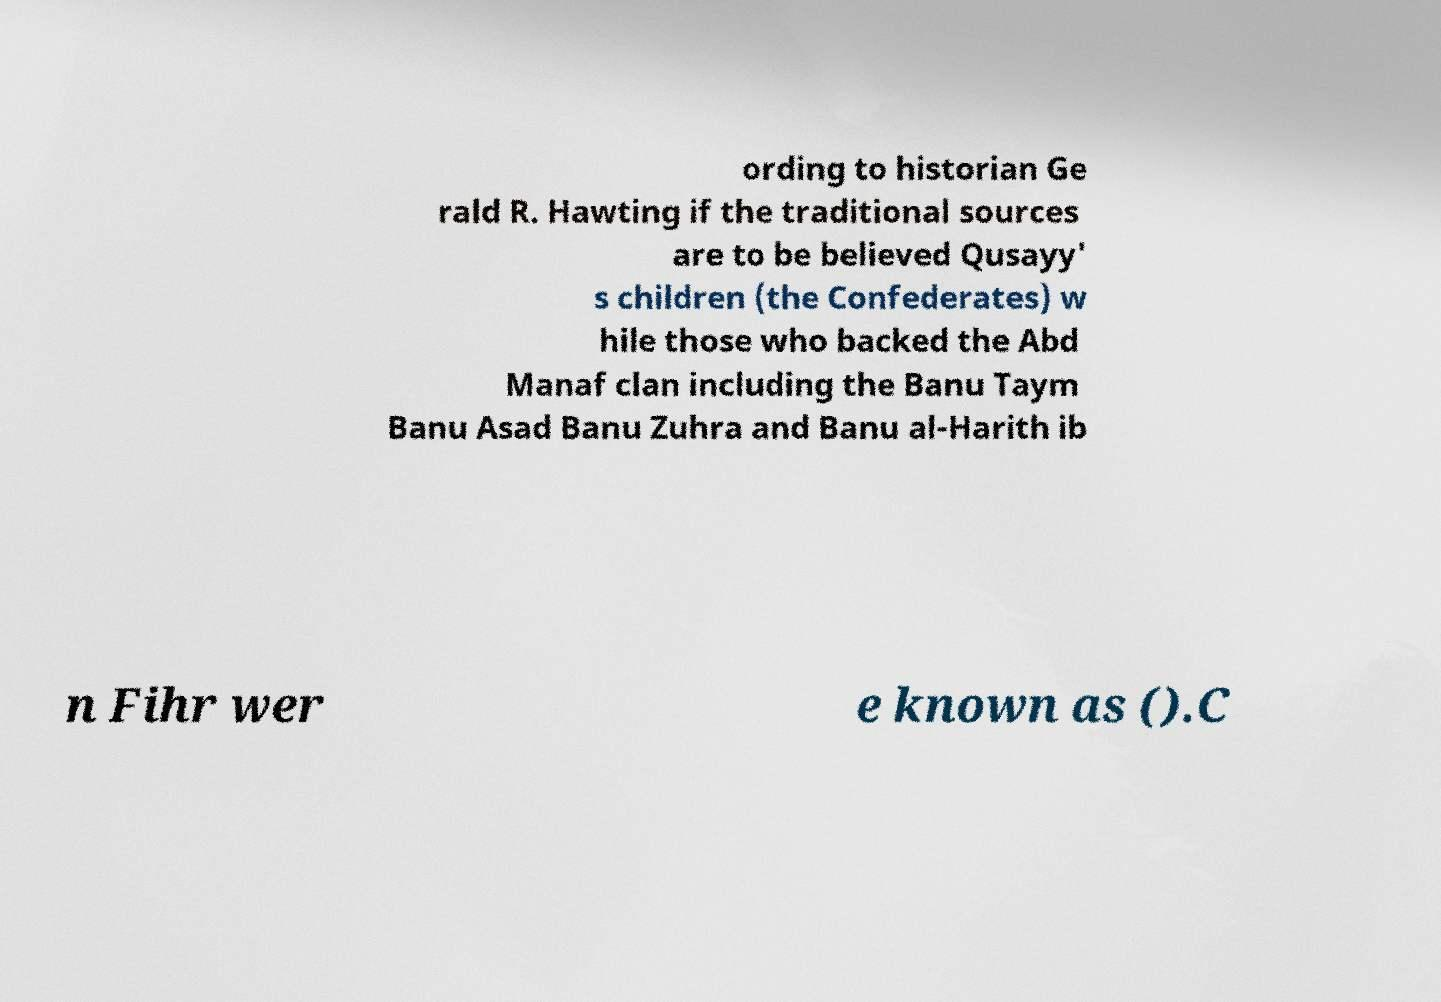For documentation purposes, I need the text within this image transcribed. Could you provide that? ording to historian Ge rald R. Hawting if the traditional sources are to be believed Qusayy' s children (the Confederates) w hile those who backed the Abd Manaf clan including the Banu Taym Banu Asad Banu Zuhra and Banu al-Harith ib n Fihr wer e known as ().C 